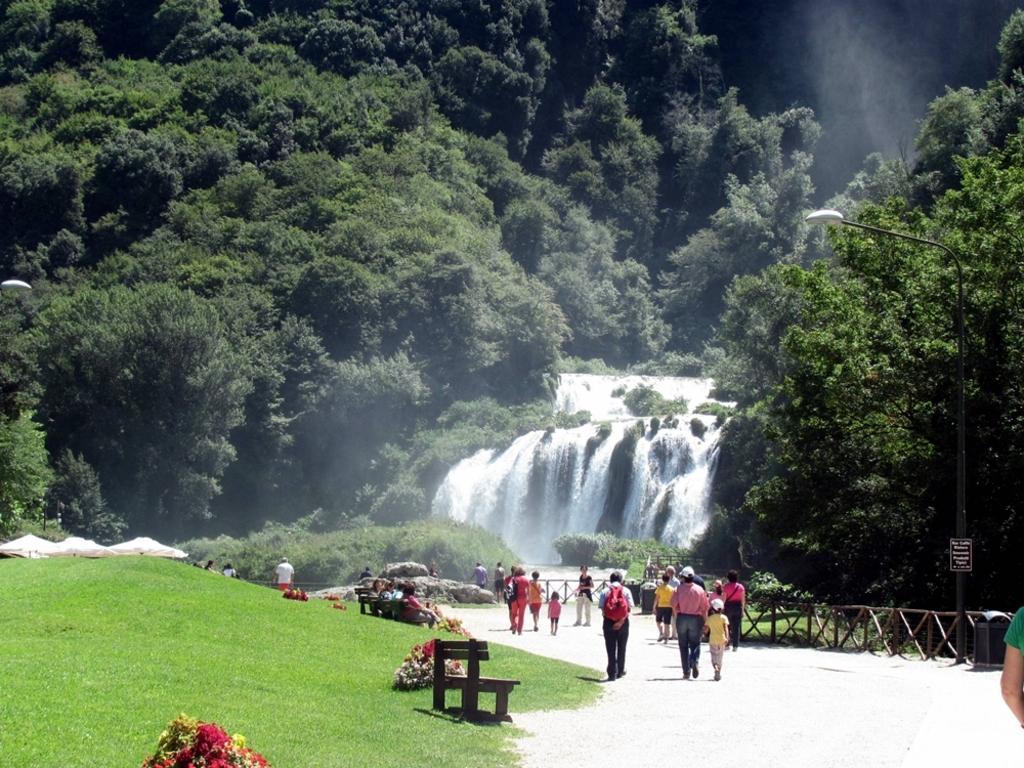Could you give a brief overview of what you see in this image? This picture describes about group of people, few are stated and few are walking, beside to them we can find benches, grass, fence and trees, and also we can see waterfalls and tents. 